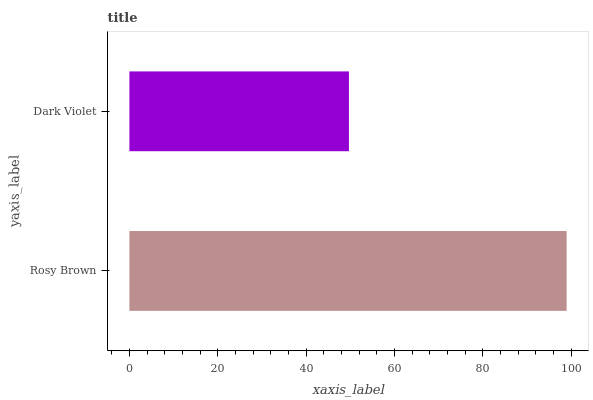Is Dark Violet the minimum?
Answer yes or no. Yes. Is Rosy Brown the maximum?
Answer yes or no. Yes. Is Dark Violet the maximum?
Answer yes or no. No. Is Rosy Brown greater than Dark Violet?
Answer yes or no. Yes. Is Dark Violet less than Rosy Brown?
Answer yes or no. Yes. Is Dark Violet greater than Rosy Brown?
Answer yes or no. No. Is Rosy Brown less than Dark Violet?
Answer yes or no. No. Is Rosy Brown the high median?
Answer yes or no. Yes. Is Dark Violet the low median?
Answer yes or no. Yes. Is Dark Violet the high median?
Answer yes or no. No. Is Rosy Brown the low median?
Answer yes or no. No. 